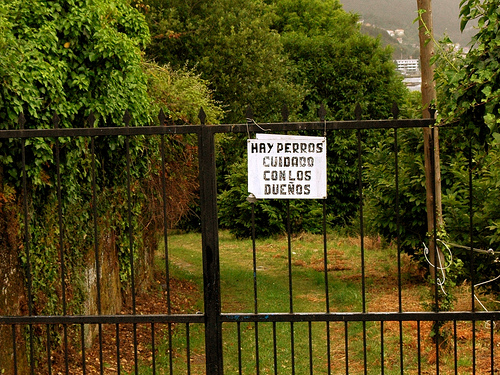<image>
Is there a sign in front of the gate? Yes. The sign is positioned in front of the gate, appearing closer to the camera viewpoint. 